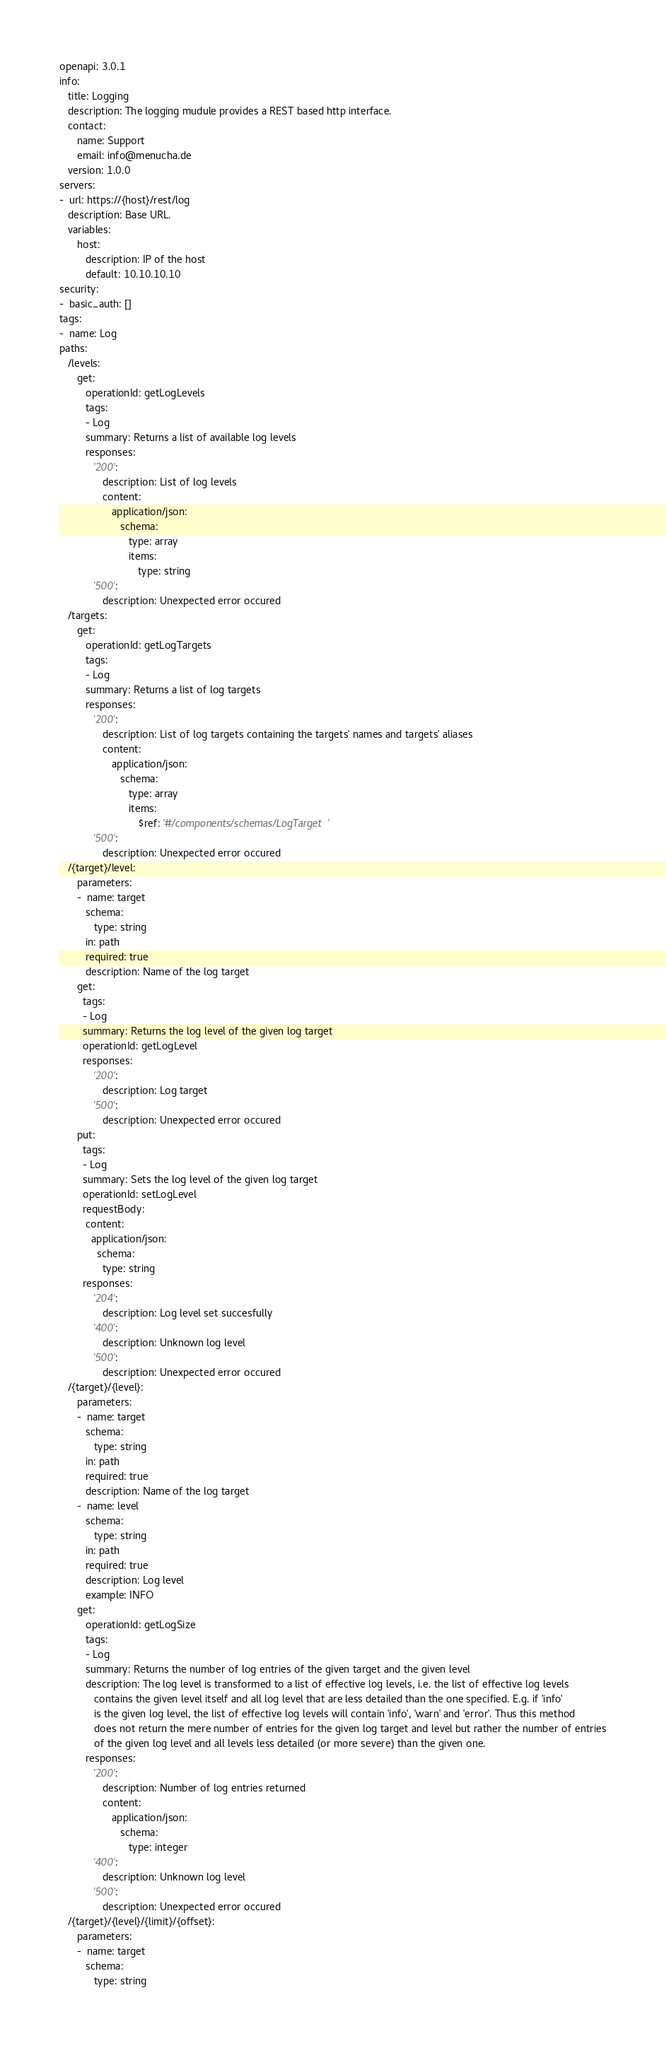Convert code to text. <code><loc_0><loc_0><loc_500><loc_500><_YAML_>openapi: 3.0.1
info:
   title: Logging
   description: The logging mudule provides a REST based http interface.
   contact:
      name: Support
      email: info@menucha.de
   version: 1.0.0
servers:
-  url: https://{host}/rest/log
   description: Base URL.
   variables:
      host:
         description: IP of the host
         default: 10.10.10.10
security:
-  basic_auth: []
tags:
-  name: Log
paths:
   /levels:
      get:
         operationId: getLogLevels
         tags:
         - Log
         summary: Returns a list of available log levels
         responses:
            '200':
               description: List of log levels
               content:
                  application/json:
                     schema:
                        type: array
                        items:
                           type: string
            '500':
               description: Unexpected error occured
   /targets:
      get:
         operationId: getLogTargets
         tags:
         - Log
         summary: Returns a list of log targets
         responses:
            '200':
               description: List of log targets containing the targets' names and targets' aliases
               content:
                  application/json:
                     schema:
                        type: array
                        items:
                           $ref: '#/components/schemas/LogTarget'
            '500':
               description: Unexpected error occured
   /{target}/level:
      parameters:
      -  name: target
         schema:
            type: string
         in: path
         required: true
         description: Name of the log target
      get:
        tags:
        - Log
        summary: Returns the log level of the given log target
        operationId: getLogLevel
        responses:
            '200':
               description: Log target
            '500':
               description: Unexpected error occured
      put:
        tags:
        - Log
        summary: Sets the log level of the given log target
        operationId: setLogLevel
        requestBody:
         content:
           application/json:
             schema:
               type: string
        responses:
            '204':
               description: Log level set succesfully
            '400':
               description: Unknown log level
            '500':
               description: Unexpected error occured
   /{target}/{level}:
      parameters:
      -  name: target
         schema:
            type: string
         in: path
         required: true
         description: Name of the log target
      -  name: level
         schema:
            type: string
         in: path
         required: true
         description: Log level
         example: INFO
      get:
         operationId: getLogSize
         tags:
         - Log
         summary: Returns the number of log entries of the given target and the given level
         description: The log level is transformed to a list of effective log levels, i.e. the list of effective log levels
            contains the given level itself and all log level that are less detailed than the one specified. E.g. if 'info'
            is the given log level, the list of effective log levels will contain 'info', 'warn' and 'error'. Thus this method
            does not return the mere number of entries for the given log target and level but rather the number of entries
            of the given log level and all levels less detailed (or more severe) than the given one.
         responses:
            '200':
               description: Number of log entries returned
               content:
                  application/json:
                     schema:
                        type: integer
            '400':
               description: Unknown log level
            '500':
               description: Unexpected error occured
   /{target}/{level}/{limit}/{offset}:
      parameters:
      -  name: target
         schema:
            type: string</code> 